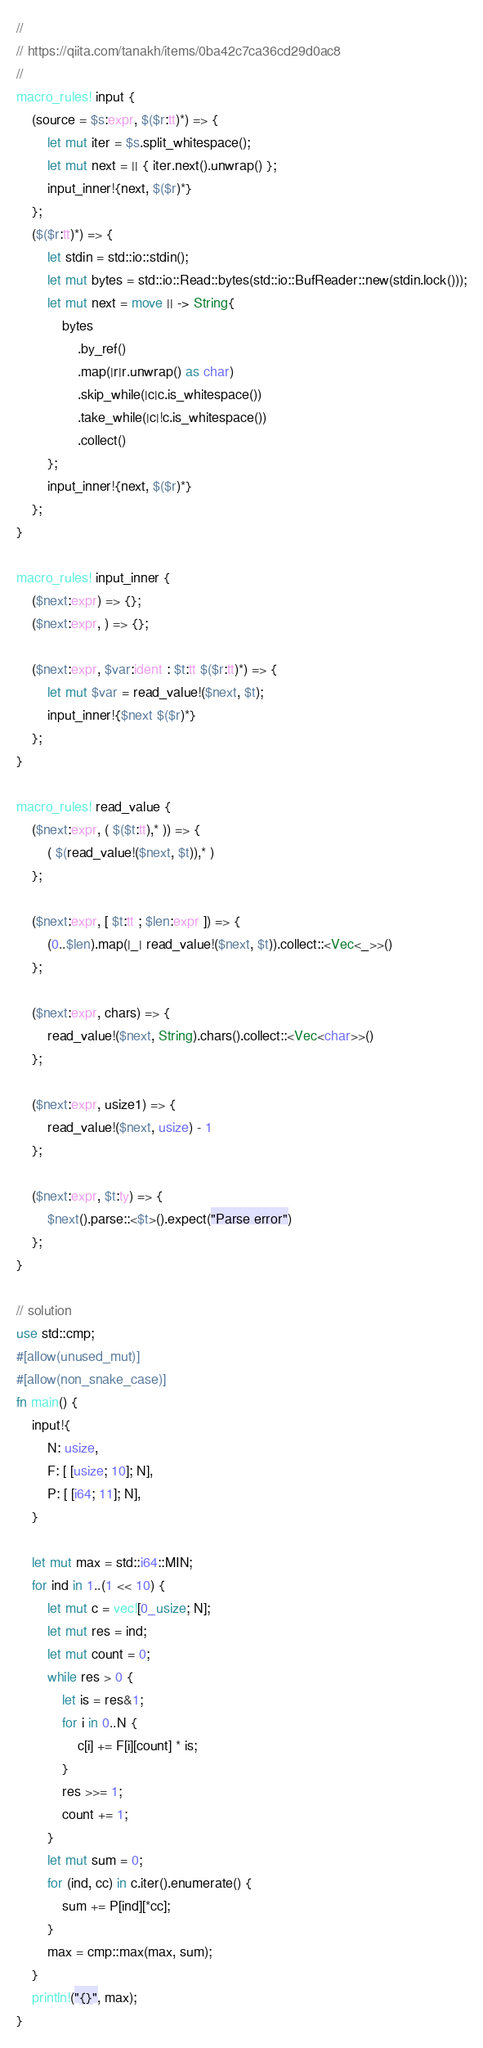Convert code to text. <code><loc_0><loc_0><loc_500><loc_500><_Rust_>//
// https://qiita.com/tanakh/items/0ba42c7ca36cd29d0ac8
//
macro_rules! input {
    (source = $s:expr, $($r:tt)*) => {
        let mut iter = $s.split_whitespace();
        let mut next = || { iter.next().unwrap() };
        input_inner!{next, $($r)*}
    };
    ($($r:tt)*) => {
        let stdin = std::io::stdin();
        let mut bytes = std::io::Read::bytes(std::io::BufReader::new(stdin.lock()));
        let mut next = move || -> String{
            bytes
                .by_ref()
                .map(|r|r.unwrap() as char)
                .skip_while(|c|c.is_whitespace())
                .take_while(|c|!c.is_whitespace())
                .collect()
        };
        input_inner!{next, $($r)*}
    };
}

macro_rules! input_inner {
    ($next:expr) => {};
    ($next:expr, ) => {};

    ($next:expr, $var:ident : $t:tt $($r:tt)*) => {
        let mut $var = read_value!($next, $t);
        input_inner!{$next $($r)*}
    };
}

macro_rules! read_value {
    ($next:expr, ( $($t:tt),* )) => {
        ( $(read_value!($next, $t)),* )
    };

    ($next:expr, [ $t:tt ; $len:expr ]) => {
        (0..$len).map(|_| read_value!($next, $t)).collect::<Vec<_>>()
    };

    ($next:expr, chars) => {
        read_value!($next, String).chars().collect::<Vec<char>>()
    };

    ($next:expr, usize1) => {
        read_value!($next, usize) - 1
    };

    ($next:expr, $t:ty) => {
        $next().parse::<$t>().expect("Parse error")
    };
}

// solution 
use std::cmp;
#[allow(unused_mut)]
#[allow(non_snake_case)]
fn main() {
    input!{
        N: usize,
        F: [ [usize; 10]; N],
        P: [ [i64; 11]; N],
    }

    let mut max = std::i64::MIN;
    for ind in 1..(1 << 10) {
        let mut c = vec![0_usize; N];
        let mut res = ind;
        let mut count = 0;
        while res > 0 {
            let is = res&1;
            for i in 0..N {
                c[i] += F[i][count] * is;
            }
            res >>= 1;
            count += 1;
        }
        let mut sum = 0;
        for (ind, cc) in c.iter().enumerate() {
            sum += P[ind][*cc];
        }
        max = cmp::max(max, sum);
    }
    println!("{}", max);
}
</code> 